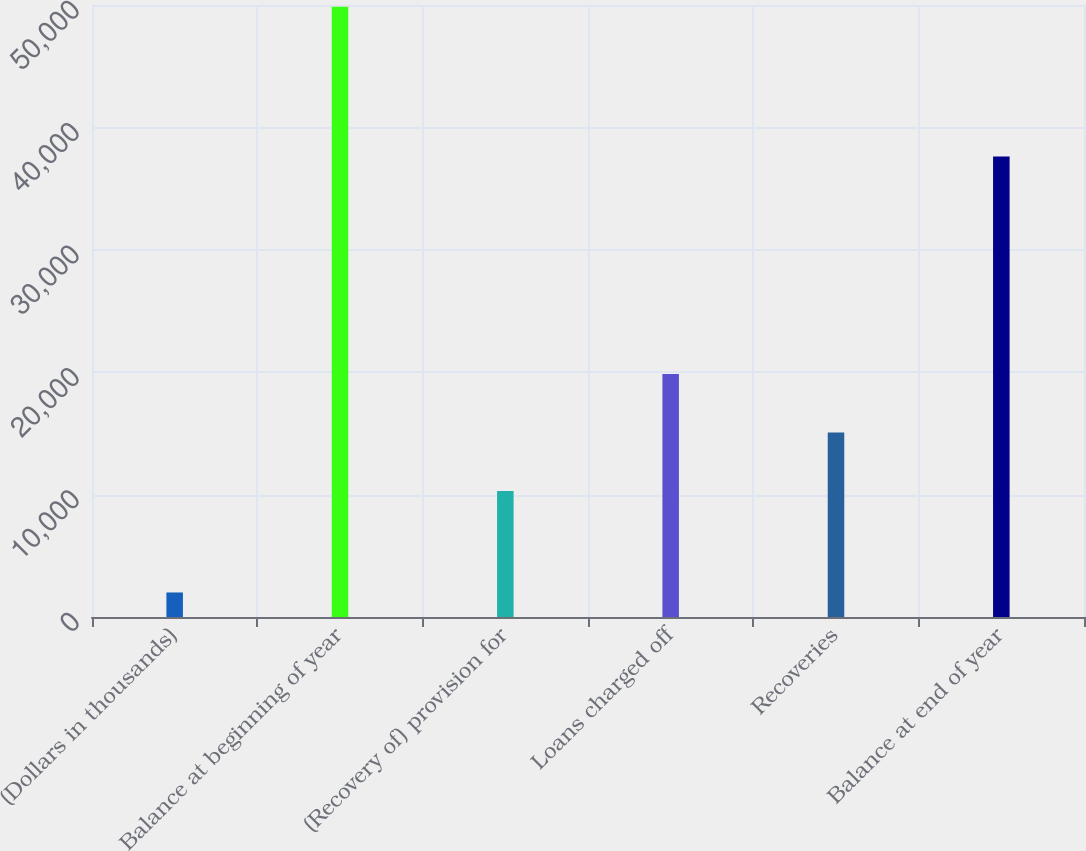<chart> <loc_0><loc_0><loc_500><loc_500><bar_chart><fcel>(Dollars in thousands)<fcel>Balance at beginning of year<fcel>(Recovery of) provision for<fcel>Loans charged off<fcel>Recoveries<fcel>Balance at end of year<nl><fcel>2004<fcel>49862<fcel>10289<fcel>19860.6<fcel>15074.8<fcel>37613<nl></chart> 